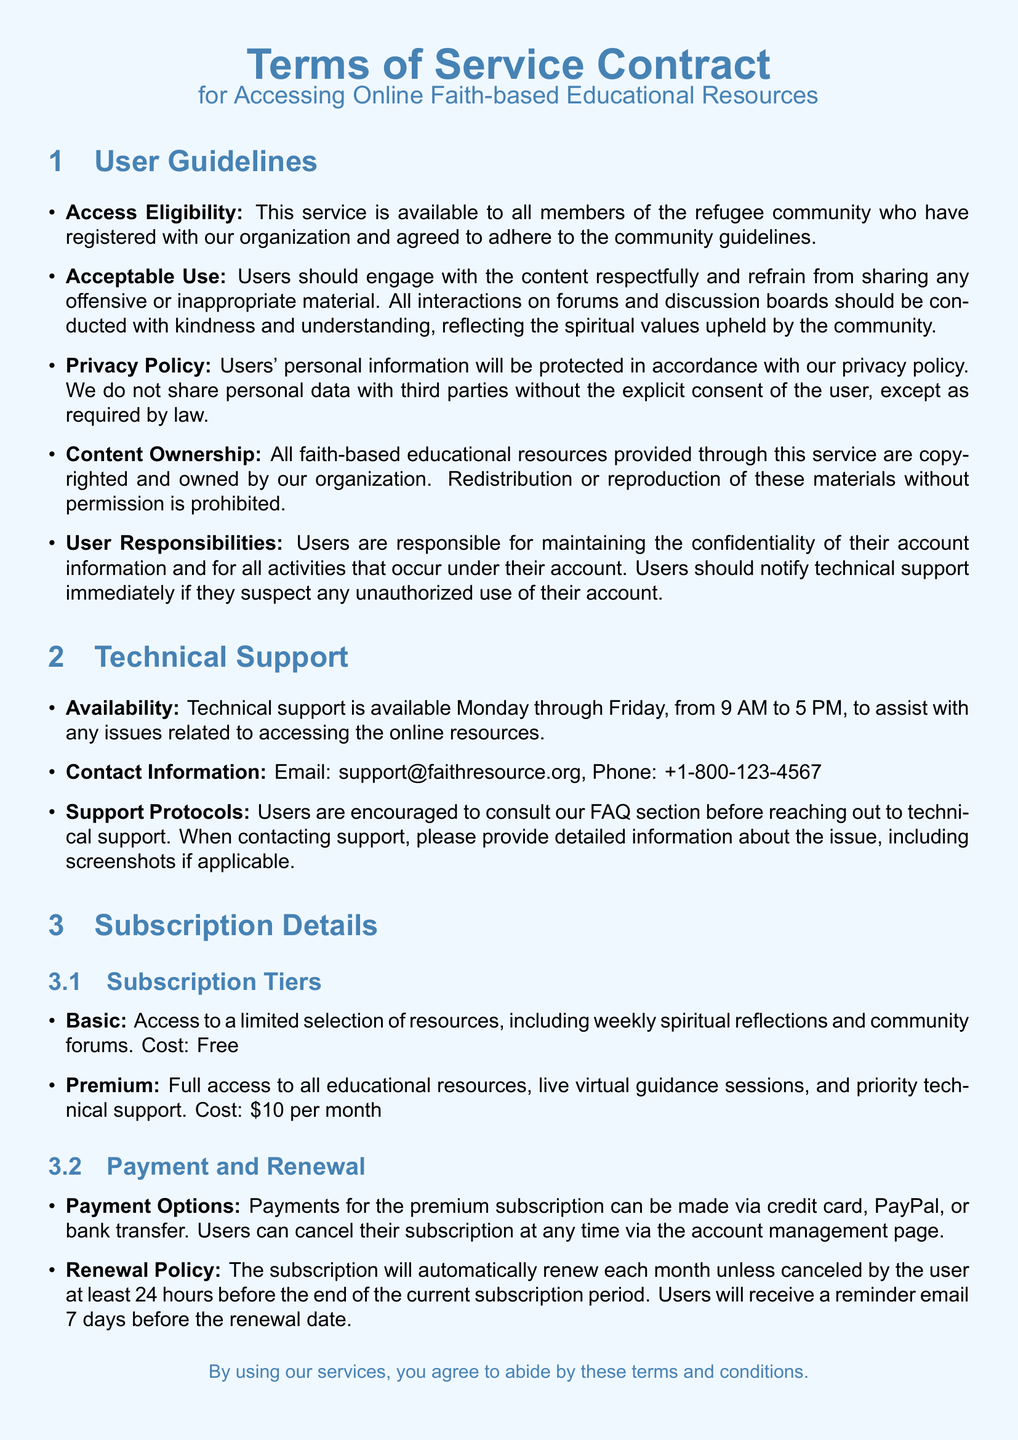What is the cost of the Premium subscription? The Premium subscription is priced at $10 per month.
Answer: $10 per month What are the technical support hours? Technical support is available from Monday through Friday, from 9 AM to 5 PM.
Answer: 9 AM to 5 PM What is required for accessing the service? Users must register with the organization and agree to adhere to the community guidelines to access the service.
Answer: Register and agree to community guidelines What should users do if they suspect unauthorized account use? Users should notify technical support immediately if they suspect any unauthorized use of their account.
Answer: Notify technical support How many days before the renewal date will users receive a reminder email? Users will receive a reminder email 7 days before the renewal date.
Answer: 7 days What is the Basic subscription tier? The Basic subscription offers access to a limited selection of resources, including weekly spiritual reflections and community forums.
Answer: Limited selection of resources What contact method is available for technical support? Users can contact technical support via email or phone.
Answer: Email or phone What will happen if a user cancels their subscription? Users can cancel their subscription at any time via the account management page.
Answer: Cancel anytime via account management page 